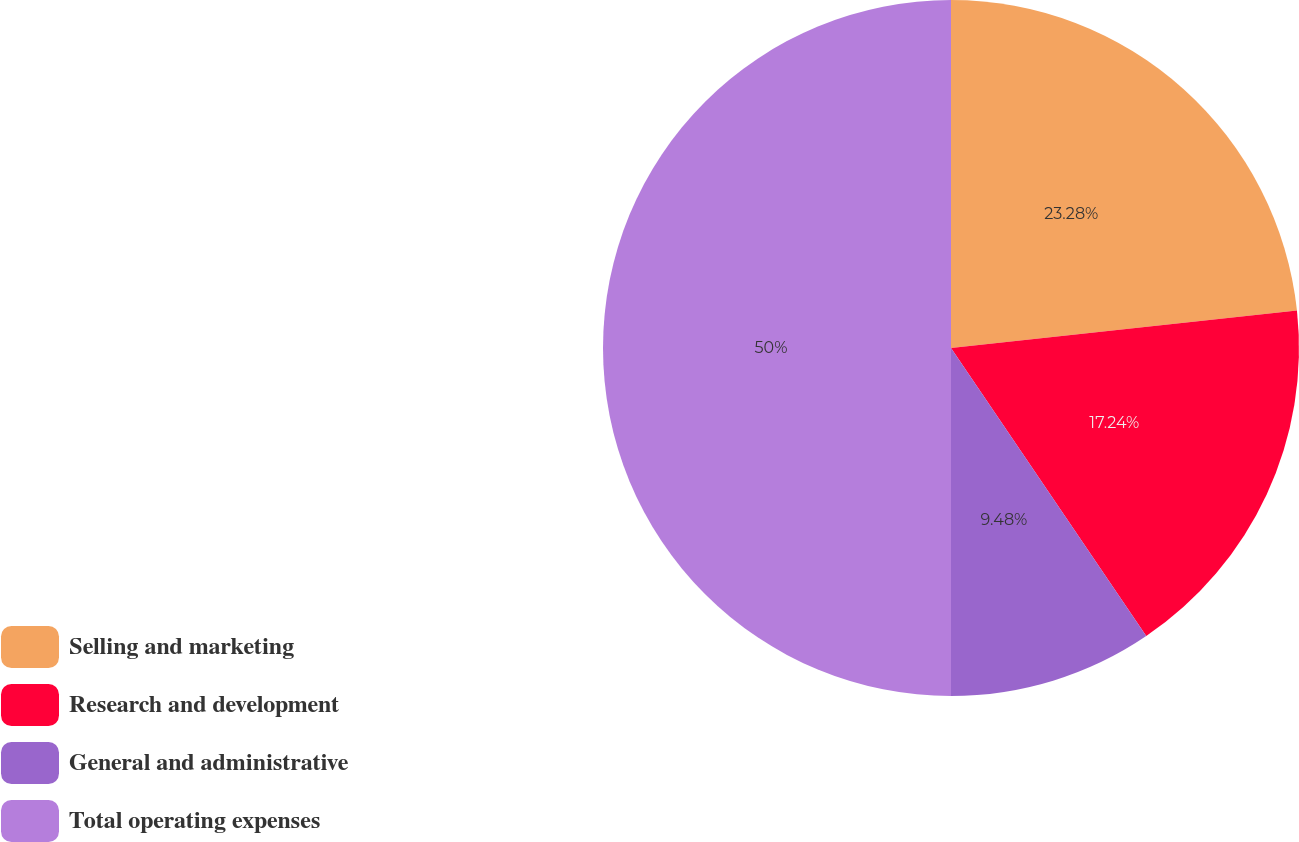Convert chart to OTSL. <chart><loc_0><loc_0><loc_500><loc_500><pie_chart><fcel>Selling and marketing<fcel>Research and development<fcel>General and administrative<fcel>Total operating expenses<nl><fcel>23.28%<fcel>17.24%<fcel>9.48%<fcel>50.0%<nl></chart> 